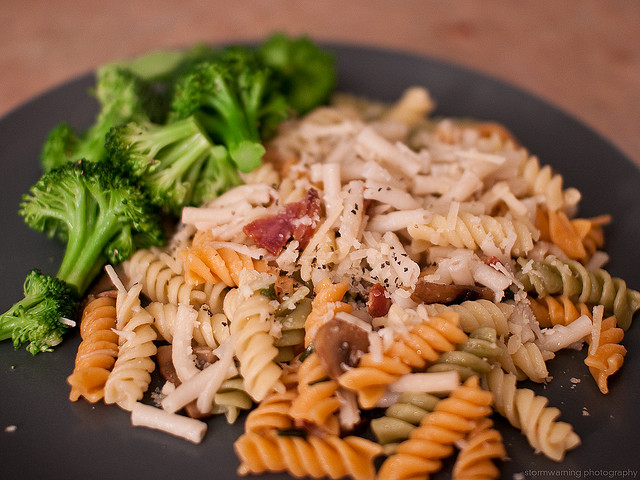<image>What is the dressing of the salad? It is not possible to determine the dressing of the salad. It could be ranch, cheese, seasoned, Italian, vinaigrette, or just salt and pepper. What is the dressing of the salad? I don't know what the dressing of the salad is. It can be 'ranch', 'cheese', 'salt and pepper', 'season', 'italian', 'vinaigrette' or none. 